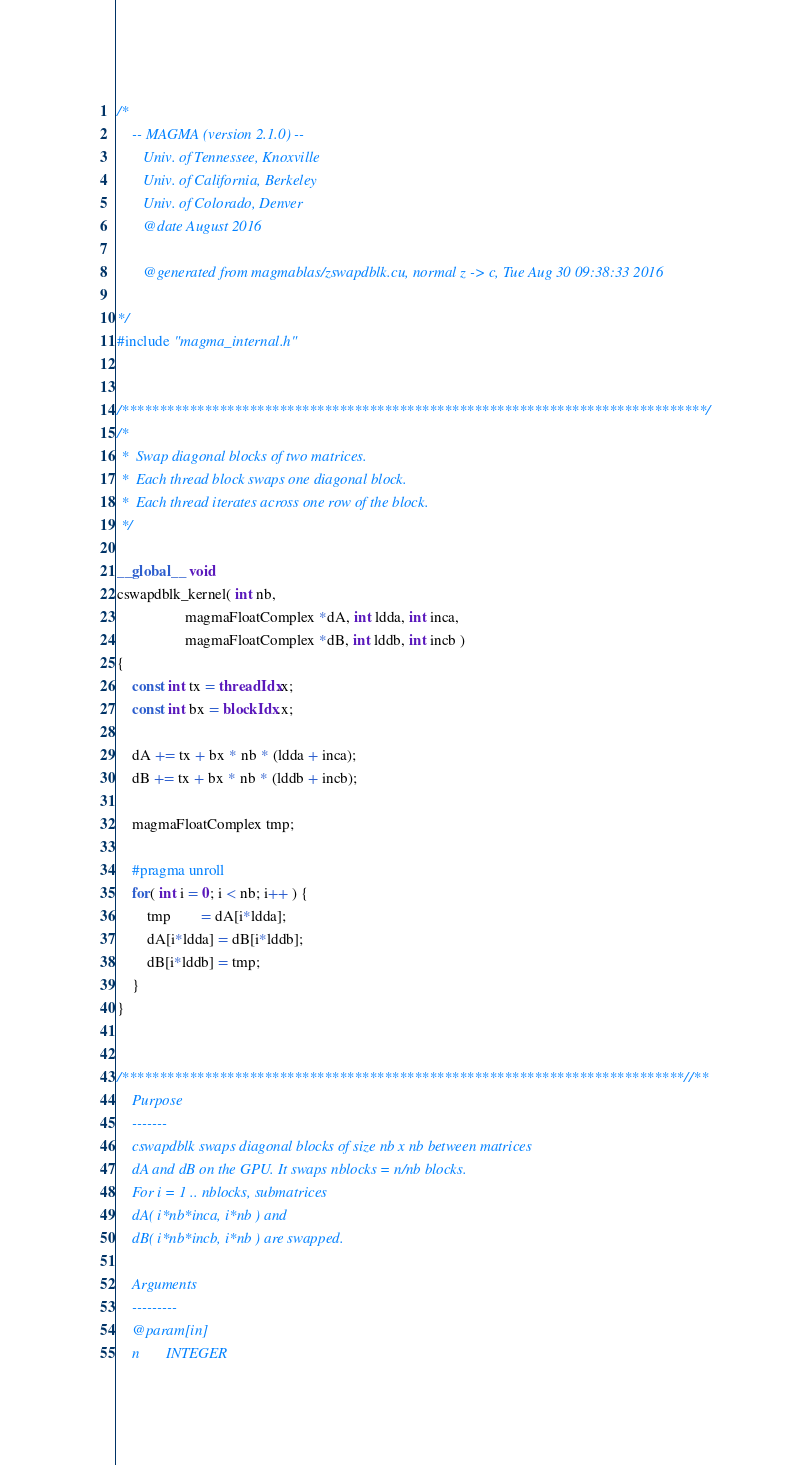Convert code to text. <code><loc_0><loc_0><loc_500><loc_500><_Cuda_>/*
    -- MAGMA (version 2.1.0) --
       Univ. of Tennessee, Knoxville
       Univ. of California, Berkeley
       Univ. of Colorado, Denver
       @date August 2016

       @generated from magmablas/zswapdblk.cu, normal z -> c, Tue Aug 30 09:38:33 2016

*/
#include "magma_internal.h"


/******************************************************************************/
/*
 *  Swap diagonal blocks of two matrices.
 *  Each thread block swaps one diagonal block.
 *  Each thread iterates across one row of the block.
 */

__global__ void 
cswapdblk_kernel( int nb,
                  magmaFloatComplex *dA, int ldda, int inca,
                  magmaFloatComplex *dB, int lddb, int incb )
{
    const int tx = threadIdx.x;
    const int bx = blockIdx.x;

    dA += tx + bx * nb * (ldda + inca);
    dB += tx + bx * nb * (lddb + incb);

    magmaFloatComplex tmp;

    #pragma unroll
    for( int i = 0; i < nb; i++ ) {
        tmp        = dA[i*ldda];
        dA[i*ldda] = dB[i*lddb];
        dB[i*lddb] = tmp;
    }
}


/***************************************************************************//**
    Purpose
    -------
    cswapdblk swaps diagonal blocks of size nb x nb between matrices
    dA and dB on the GPU. It swaps nblocks = n/nb blocks.
    For i = 1 .. nblocks, submatrices
    dA( i*nb*inca, i*nb ) and
    dB( i*nb*incb, i*nb ) are swapped.
    
    Arguments
    ---------
    @param[in]
    n       INTEGER</code> 